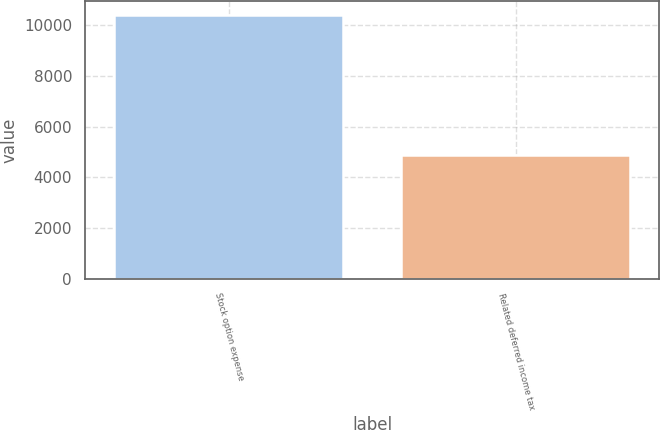Convert chart to OTSL. <chart><loc_0><loc_0><loc_500><loc_500><bar_chart><fcel>Stock option expense<fcel>Related deferred income tax<nl><fcel>10420<fcel>4886<nl></chart> 